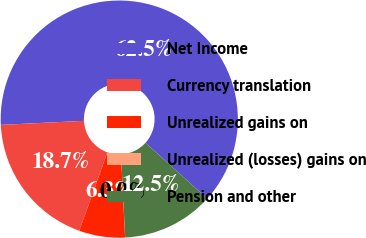<chart> <loc_0><loc_0><loc_500><loc_500><pie_chart><fcel>Net Income<fcel>Currency translation<fcel>Unrealized gains on<fcel>Unrealized (losses) gains on<fcel>Pension and other<nl><fcel>62.47%<fcel>18.75%<fcel>6.26%<fcel>0.01%<fcel>12.51%<nl></chart> 